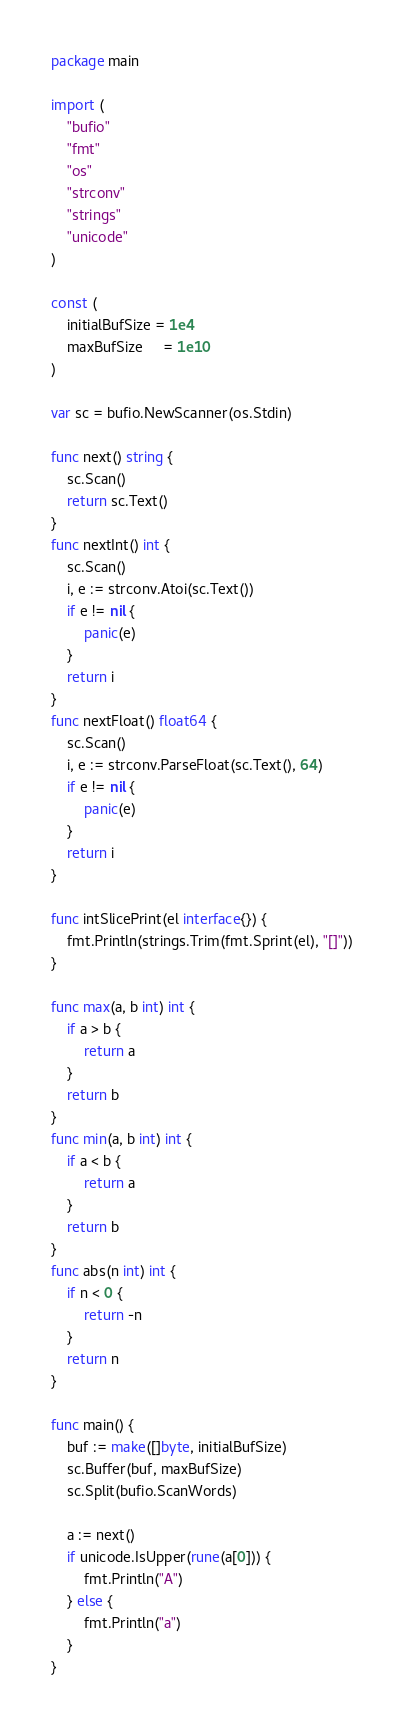Convert code to text. <code><loc_0><loc_0><loc_500><loc_500><_Go_>package main

import (
	"bufio"
	"fmt"
	"os"
	"strconv"
	"strings"
	"unicode"
)

const (
	initialBufSize = 1e4
	maxBufSize     = 1e10
)

var sc = bufio.NewScanner(os.Stdin)

func next() string {
	sc.Scan()
	return sc.Text()
}
func nextInt() int {
	sc.Scan()
	i, e := strconv.Atoi(sc.Text())
	if e != nil {
		panic(e)
	}
	return i
}
func nextFloat() float64 {
	sc.Scan()
	i, e := strconv.ParseFloat(sc.Text(), 64)
	if e != nil {
		panic(e)
	}
	return i
}

func intSlicePrint(el interface{}) {
	fmt.Println(strings.Trim(fmt.Sprint(el), "[]"))
}

func max(a, b int) int {
	if a > b {
		return a
	}
	return b
}
func min(a, b int) int {
	if a < b {
		return a
	}
	return b
}
func abs(n int) int {
	if n < 0 {
		return -n
	}
	return n
}

func main() {
	buf := make([]byte, initialBufSize)
	sc.Buffer(buf, maxBufSize)
	sc.Split(bufio.ScanWords)

	a := next()
	if unicode.IsUpper(rune(a[0])) {
		fmt.Println("A")
	} else {
		fmt.Println("a")
	}
}

</code> 